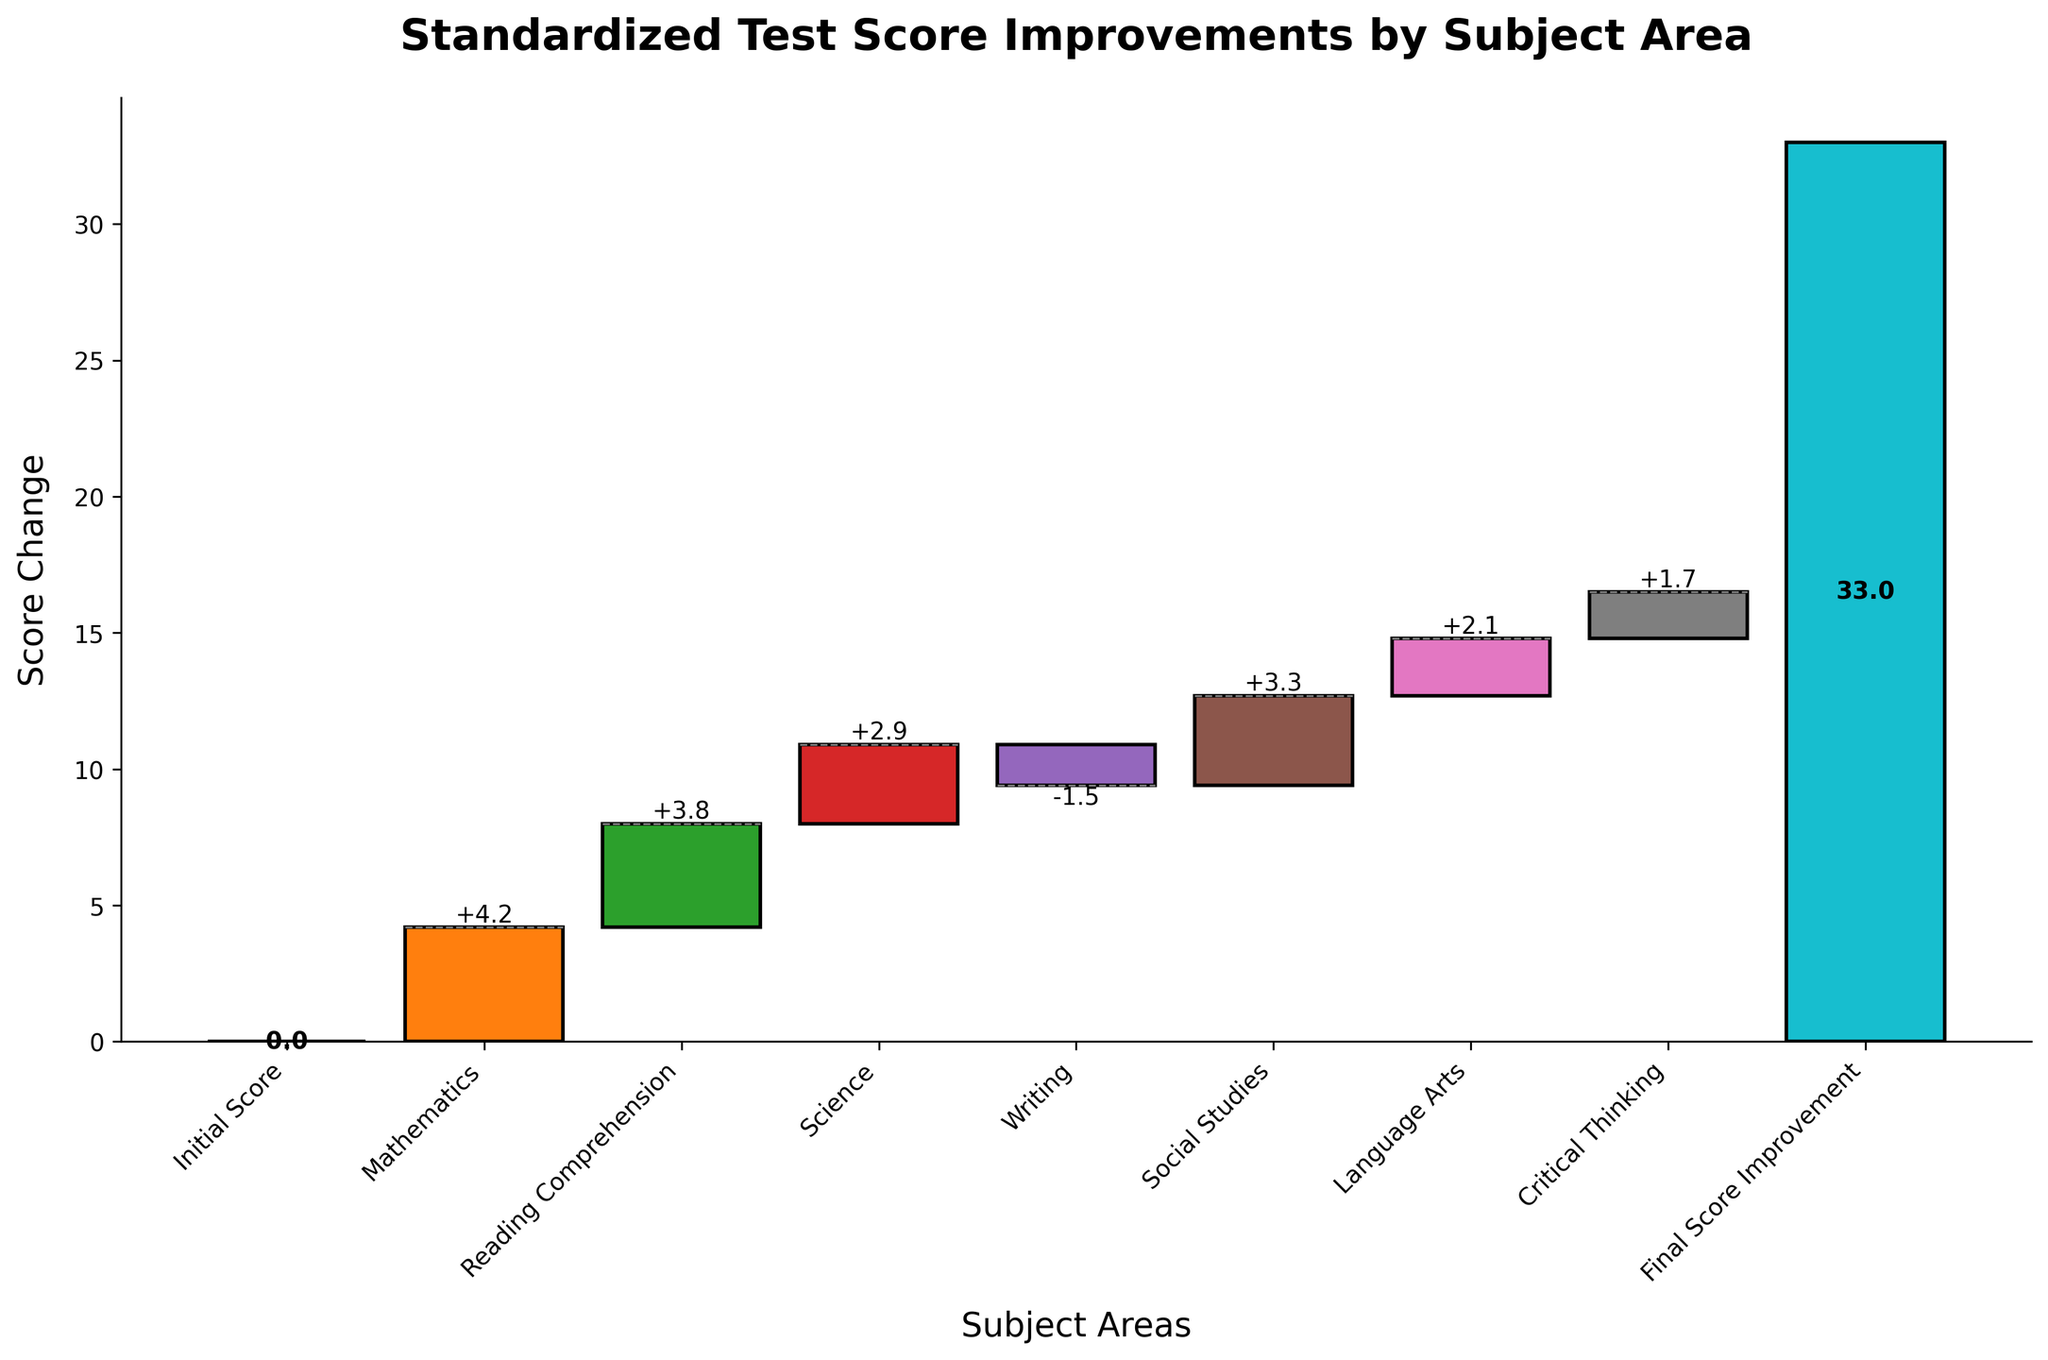What is the title of the chart? The title of the chart is usually written at the top of the plot. It indicates the main focus of the chart.
Answer: Standardized Test Score Improvements by Subject Area How many subject areas are analyzed in the chart? Count the number of unique subject areas listed along the x-axis in the chart. The initial and final score improvements are not considered subject areas.
Answer: 7 Which subject area showed the highest improvement? Look for the tallest positive bar in the chart, representing the subject area with the highest score change.
Answer: Mathematics Which subject area had a negative score change? Identify the bar that is below the zero line indicating a score decrease.
Answer: Writing What is the cumulative score improvement at the end of the semester? The final score improvement is typically computed as the cumulative sum of all score changes, shown as the final bar.
Answer: 16.5 How much did Reading Comprehension scores improve? Look for the specific bar corresponding to Reading Comprehension and note its value.
Answer: 3.8 Which subject area had the smallest positive score change? Compare the heights of all positive bars and find the one with the smallest height.
Answer: Critical Thinking 